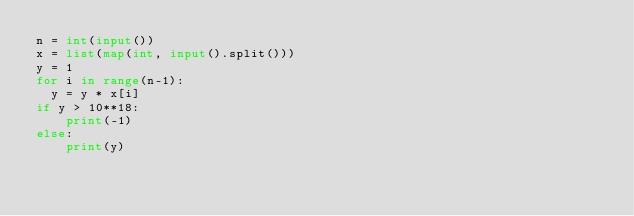Convert code to text. <code><loc_0><loc_0><loc_500><loc_500><_Python_>n = int(input()) 
x = list(map(int, input().split()))
y = 1
for i in range(n-1):
	y = y * x[i]
if y > 10**18:
  	print(-1)
else:
  	print(y)</code> 